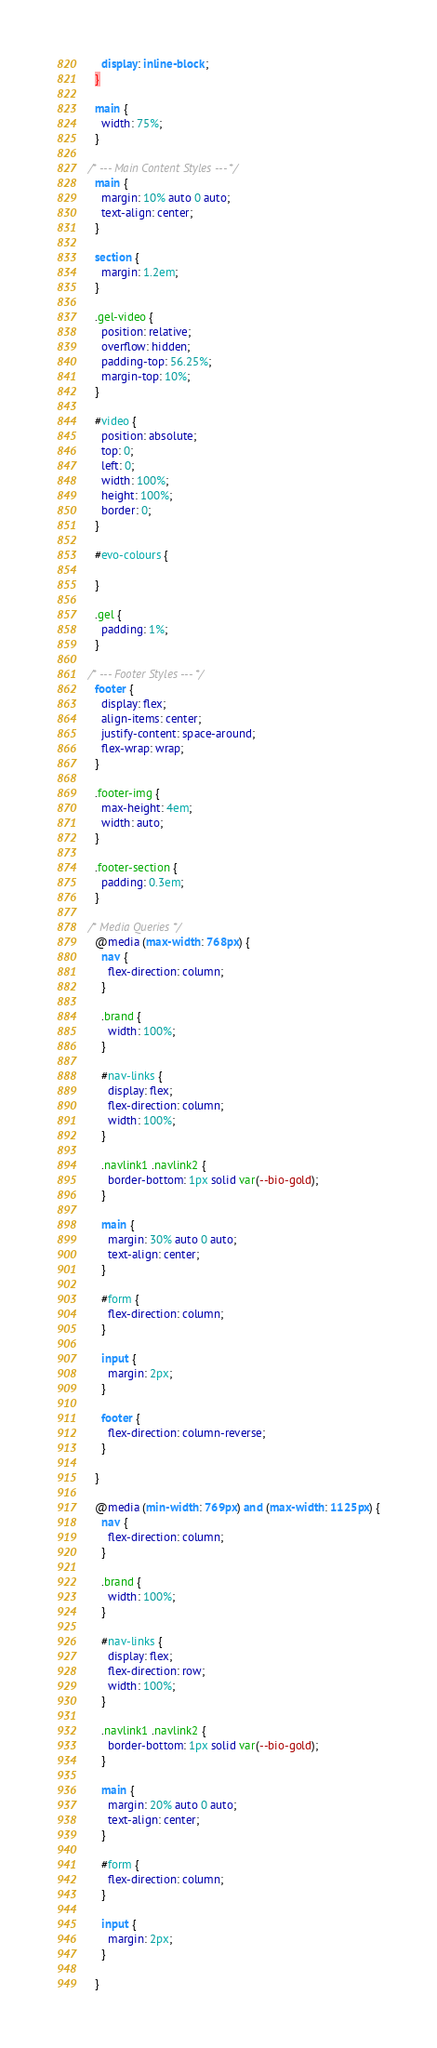<code> <loc_0><loc_0><loc_500><loc_500><_CSS_>    display: inline-block;
  }

  main {
    width: 75%;
  }

/* --- Main Content Styles --- */
  main {
    margin: 10% auto 0 auto;
    text-align: center;
  }

  section {
    margin: 1.2em;
  }

  .gel-video {
    position: relative;
    overflow: hidden;
    padding-top: 56.25%;
    margin-top: 10%;
  }

  #video {
    position: absolute;
    top: 0;
    left: 0;
    width: 100%;
    height: 100%;
    border: 0;
  }

  #evo-colours {

  }

  .gel {
    padding: 1%;
  }

/* --- Footer Styles --- */
  footer {
    display: flex;
    align-items: center;
    justify-content: space-around;
    flex-wrap: wrap;
  }

  .footer-img {
    max-height: 4em;
    width: auto;  
  }

  .footer-section {
    padding: 0.3em;
  }

/* Media Queries */
  @media (max-width: 768px) {
    nav {
      flex-direction: column;
    }

    .brand {
      width: 100%;
    }

    #nav-links {
      display: flex;
      flex-direction: column;
      width: 100%;
    }

    .navlink1 .navlink2 {
      border-bottom: 1px solid var(--bio-gold);
    }

    main {
      margin: 30% auto 0 auto;
      text-align: center;
    }

    #form {
      flex-direction: column;
    }

    input {
      margin: 2px;
    }

    footer {
      flex-direction: column-reverse;
    }

  }

  @media (min-width: 769px) and (max-width: 1125px) {
    nav {
      flex-direction: column;
    }

    .brand {
      width: 100%;
    }

    #nav-links {
      display: flex;
      flex-direction: row;
      width: 100%;
    }

    .navlink1 .navlink2 {
      border-bottom: 1px solid var(--bio-gold);
    }

    main {
      margin: 20% auto 0 auto;
      text-align: center;
    }

    #form {
      flex-direction: column;
    }

    input {
      margin: 2px;
    }

  }</code> 